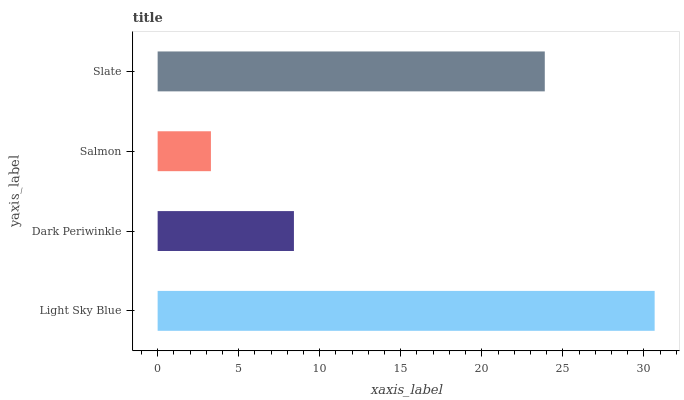Is Salmon the minimum?
Answer yes or no. Yes. Is Light Sky Blue the maximum?
Answer yes or no. Yes. Is Dark Periwinkle the minimum?
Answer yes or no. No. Is Dark Periwinkle the maximum?
Answer yes or no. No. Is Light Sky Blue greater than Dark Periwinkle?
Answer yes or no. Yes. Is Dark Periwinkle less than Light Sky Blue?
Answer yes or no. Yes. Is Dark Periwinkle greater than Light Sky Blue?
Answer yes or no. No. Is Light Sky Blue less than Dark Periwinkle?
Answer yes or no. No. Is Slate the high median?
Answer yes or no. Yes. Is Dark Periwinkle the low median?
Answer yes or no. Yes. Is Dark Periwinkle the high median?
Answer yes or no. No. Is Slate the low median?
Answer yes or no. No. 